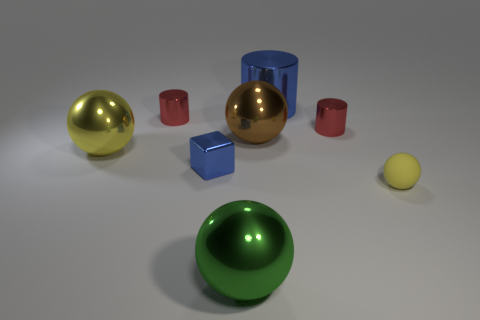Is there anything else that is the same material as the small yellow thing?
Your answer should be compact. No. There is a shiny ball in front of the tiny yellow thing; are there any tiny yellow matte spheres that are in front of it?
Make the answer very short. No. There is a big yellow thing; is it the same shape as the small red metallic thing that is to the left of the big brown metal object?
Ensure brevity in your answer.  No. The big metal sphere that is in front of the small rubber sphere is what color?
Make the answer very short. Green. There is a metal sphere behind the yellow object behind the matte thing; what is its size?
Provide a short and direct response. Large. There is a tiny red thing right of the big green shiny ball; is it the same shape as the brown shiny object?
Your answer should be compact. No. What is the material of the other green thing that is the same shape as the matte thing?
Offer a very short reply. Metal. How many objects are either big balls behind the big green thing or red metal things right of the large green ball?
Give a very brief answer. 3. There is a rubber sphere; is its color the same as the cylinder that is on the left side of the big cylinder?
Keep it short and to the point. No. What is the shape of the green thing that is the same material as the large yellow thing?
Make the answer very short. Sphere. 